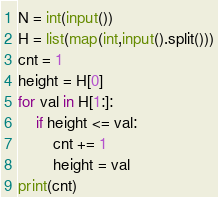Convert code to text. <code><loc_0><loc_0><loc_500><loc_500><_Python_>N = int(input())
H = list(map(int,input().split()))
cnt = 1
height = H[0]
for val in H[1:]:
    if height <= val:
        cnt += 1
        height = val
print(cnt)</code> 